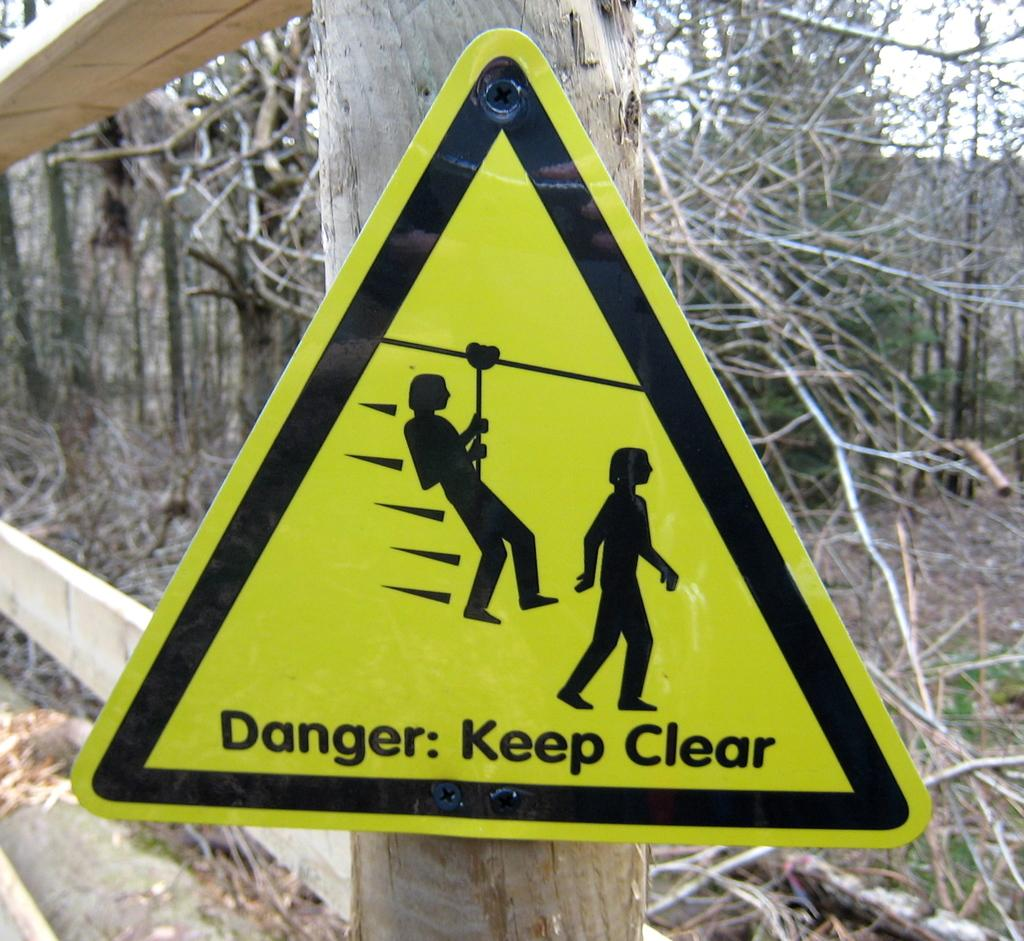What is the main object in the image? There is a signboard in the image. How is the signboard supported? The signboard is on a wooden pole. What can be seen in the distance in the image? There are trees in the background of the image. What type of canvas is being used to create the wire sculpture in the image? There is no canvas or wire sculpture present in the image; it features a signboard on a wooden pole with trees in the background. 